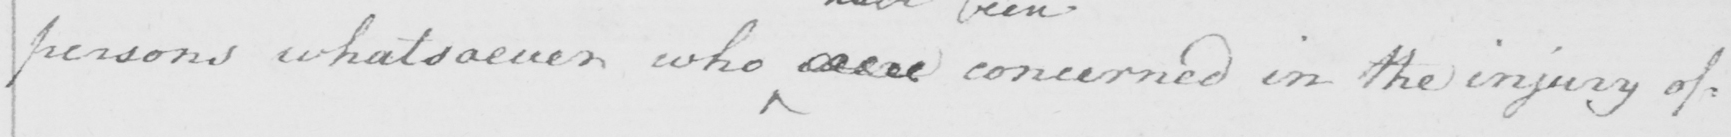Please transcribe the handwritten text in this image. persons whatsoever who were concerned in the injury of= 